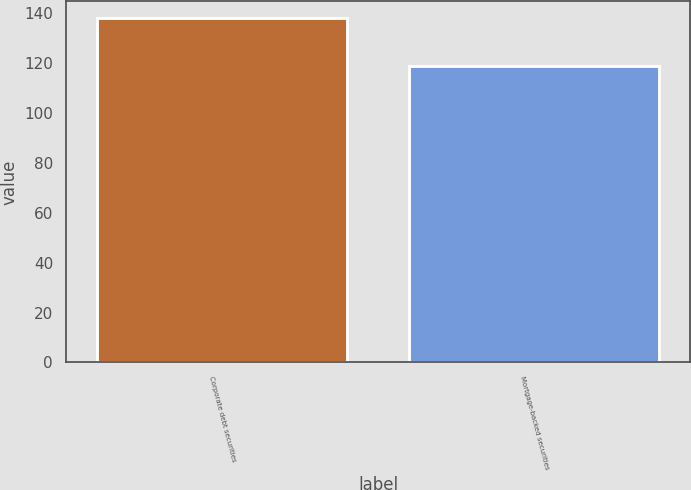<chart> <loc_0><loc_0><loc_500><loc_500><bar_chart><fcel>Corporate debt securities<fcel>Mortgage-backed securities<nl><fcel>138<fcel>119<nl></chart> 